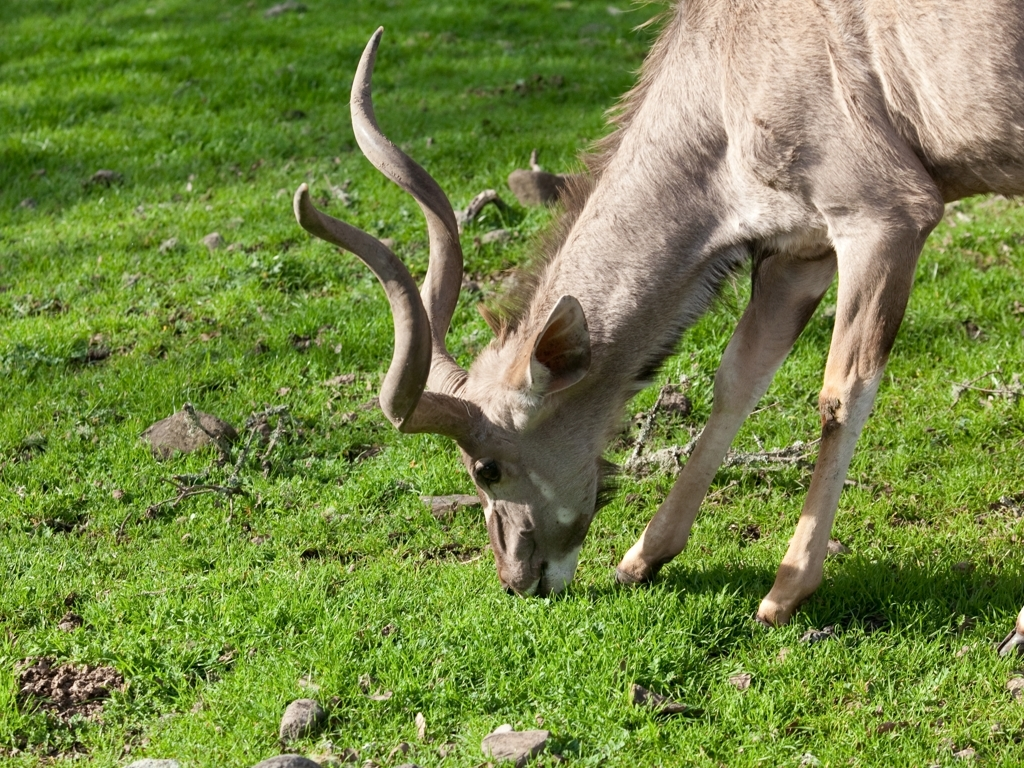What might the deer be doing at this moment? Based on the image, the deer appears to be foraging for food—likely grazing on the fresh grass, an activity that generally makes up a significant part of its daily routine. 